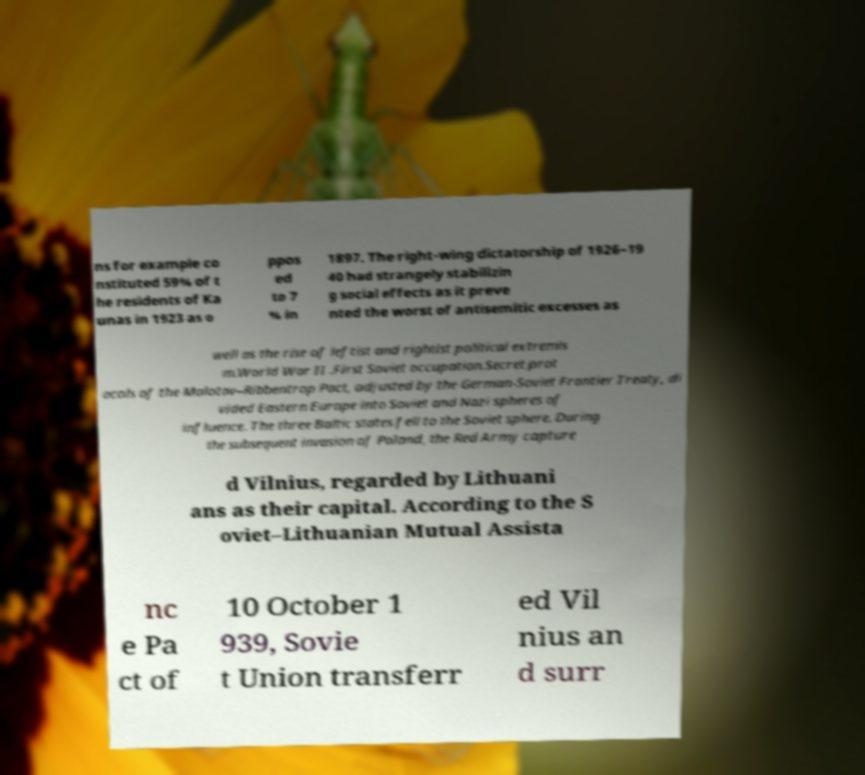Could you assist in decoding the text presented in this image and type it out clearly? ns for example co nstituted 59% of t he residents of Ka unas in 1923 as o ppos ed to 7 % in 1897. The right-wing dictatorship of 1926–19 40 had strangely stabilizin g social effects as it preve nted the worst of antisemitic excesses as well as the rise of leftist and rightist political extremis m.World War II .First Soviet occupation.Secret prot ocols of the Molotov–Ribbentrop Pact, adjusted by the German-Soviet Frontier Treaty, di vided Eastern Europe into Soviet and Nazi spheres of influence. The three Baltic states fell to the Soviet sphere. During the subsequent invasion of Poland, the Red Army capture d Vilnius, regarded by Lithuani ans as their capital. According to the S oviet–Lithuanian Mutual Assista nc e Pa ct of 10 October 1 939, Sovie t Union transferr ed Vil nius an d surr 